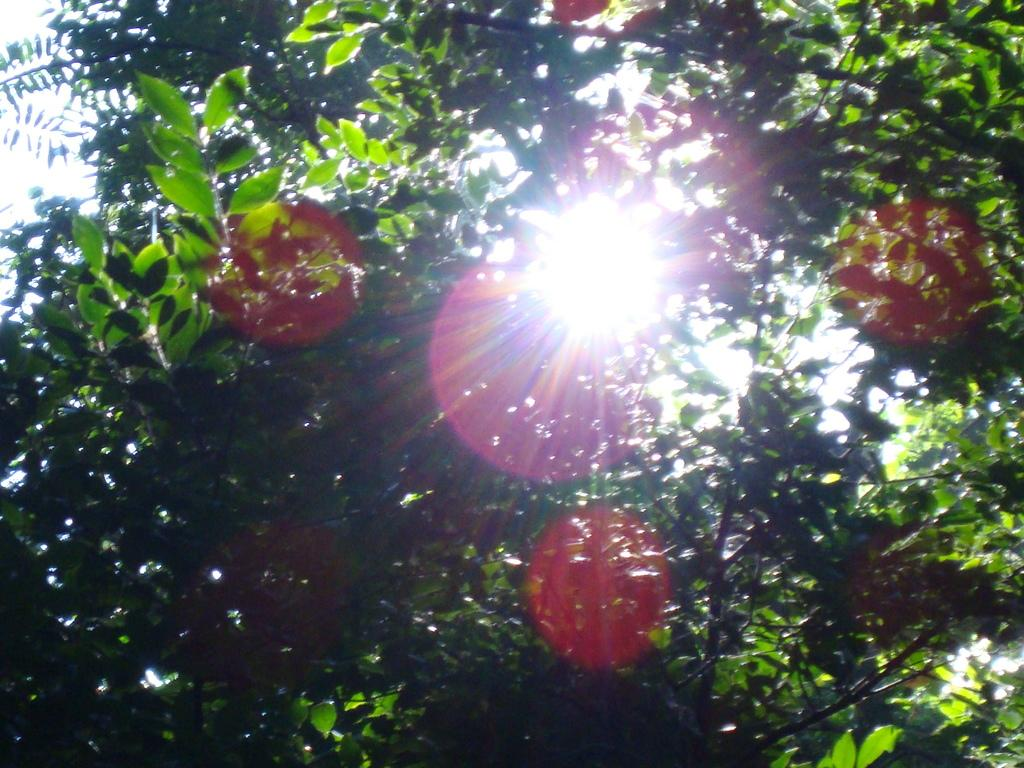What type of natural element can be seen in the image? There is a tree in the image. What is the source of light in the image? Sunlight is visible in the image. What type of transportation is available at the airport in the image? There is no airport present in the image, so it is not possible to determine what type of transportation might be available. 